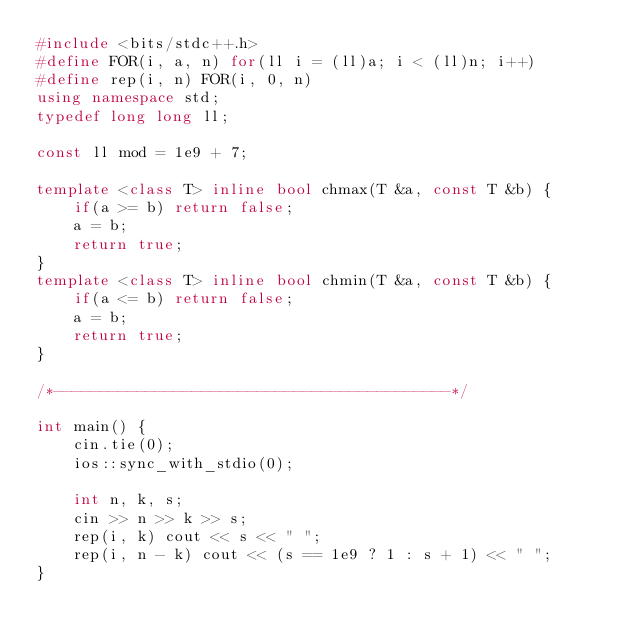Convert code to text. <code><loc_0><loc_0><loc_500><loc_500><_C++_>#include <bits/stdc++.h>
#define FOR(i, a, n) for(ll i = (ll)a; i < (ll)n; i++)
#define rep(i, n) FOR(i, 0, n)
using namespace std;
typedef long long ll;

const ll mod = 1e9 + 7;

template <class T> inline bool chmax(T &a, const T &b) {
    if(a >= b) return false;
    a = b;
    return true;
}
template <class T> inline bool chmin(T &a, const T &b) {
    if(a <= b) return false;
    a = b;
    return true;
}

/*-------------------------------------------*/

int main() {
    cin.tie(0);
    ios::sync_with_stdio(0);

    int n, k, s;
    cin >> n >> k >> s;
    rep(i, k) cout << s << " ";
    rep(i, n - k) cout << (s == 1e9 ? 1 : s + 1) << " ";
}
</code> 